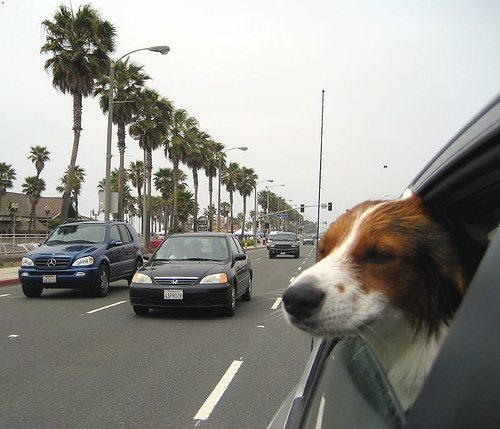Describe the objects in this image and their specific colors. I can see dog in white, black, gray, and maroon tones, car in white, black, gray, darkgray, and purple tones, car in white, darkgray, black, gray, and lightgray tones, car in white, black, darkgray, and gray tones, and car in white, black, gray, and darkgray tones in this image. 